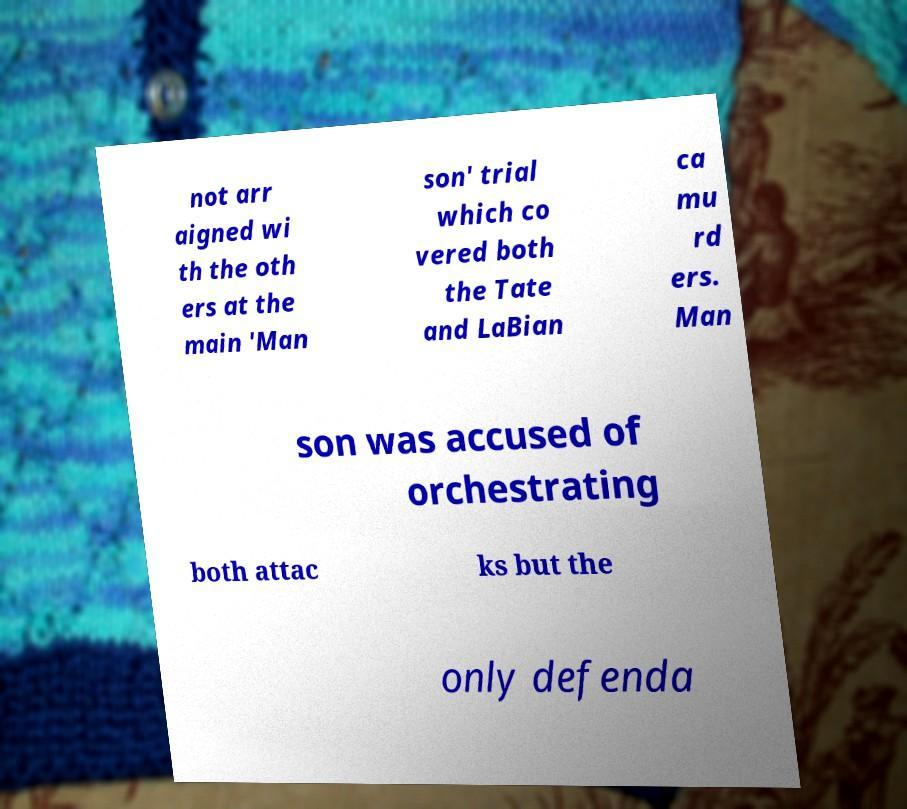There's text embedded in this image that I need extracted. Can you transcribe it verbatim? not arr aigned wi th the oth ers at the main 'Man son' trial which co vered both the Tate and LaBian ca mu rd ers. Man son was accused of orchestrating both attac ks but the only defenda 